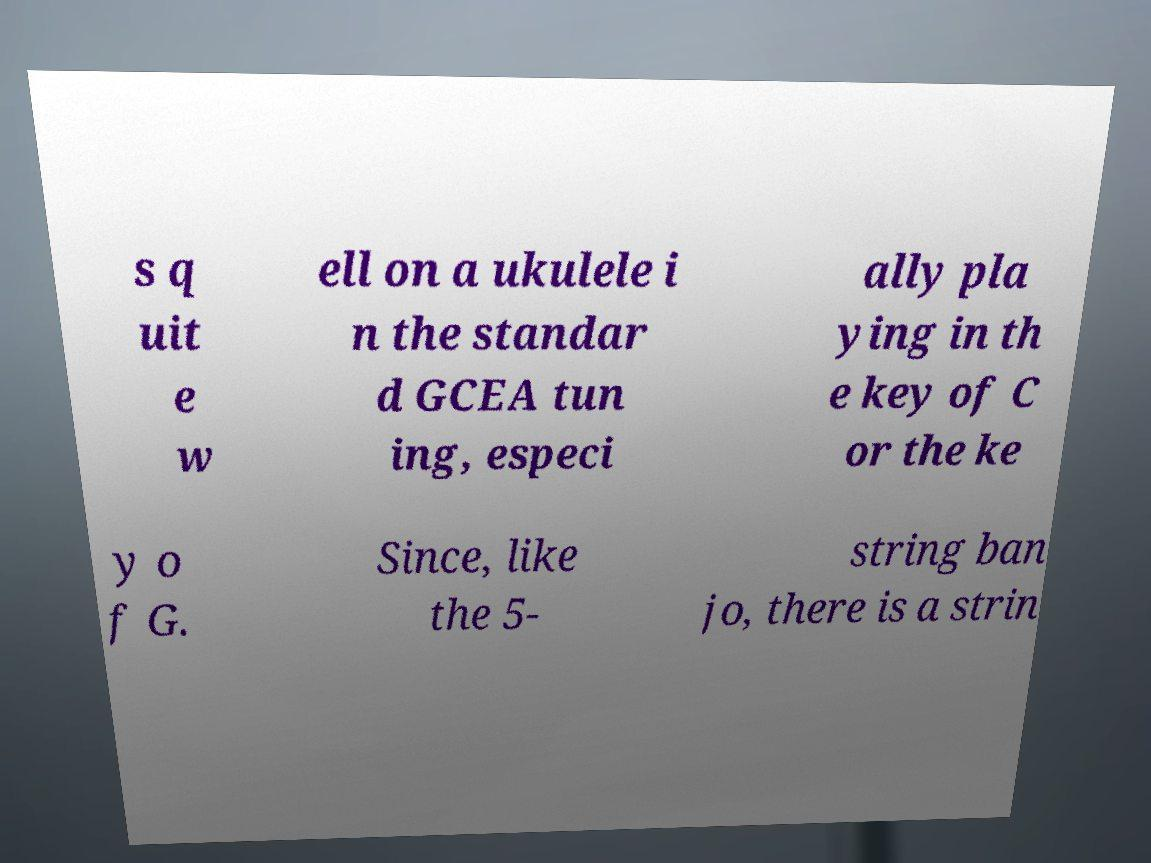What messages or text are displayed in this image? I need them in a readable, typed format. s q uit e w ell on a ukulele i n the standar d GCEA tun ing, especi ally pla ying in th e key of C or the ke y o f G. Since, like the 5- string ban jo, there is a strin 